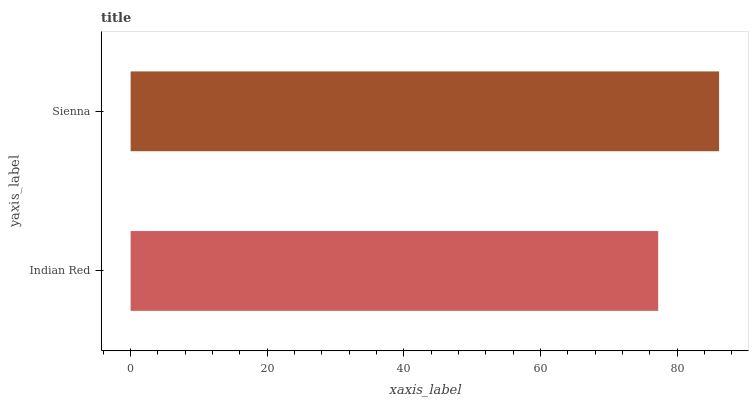Is Indian Red the minimum?
Answer yes or no. Yes. Is Sienna the maximum?
Answer yes or no. Yes. Is Sienna the minimum?
Answer yes or no. No. Is Sienna greater than Indian Red?
Answer yes or no. Yes. Is Indian Red less than Sienna?
Answer yes or no. Yes. Is Indian Red greater than Sienna?
Answer yes or no. No. Is Sienna less than Indian Red?
Answer yes or no. No. Is Sienna the high median?
Answer yes or no. Yes. Is Indian Red the low median?
Answer yes or no. Yes. Is Indian Red the high median?
Answer yes or no. No. Is Sienna the low median?
Answer yes or no. No. 